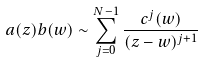Convert formula to latex. <formula><loc_0><loc_0><loc_500><loc_500>a ( z ) b ( w ) \sim \sum ^ { N - 1 } _ { j = 0 } \frac { c ^ { j } ( w ) } { ( z - w ) ^ { j + 1 } }</formula> 